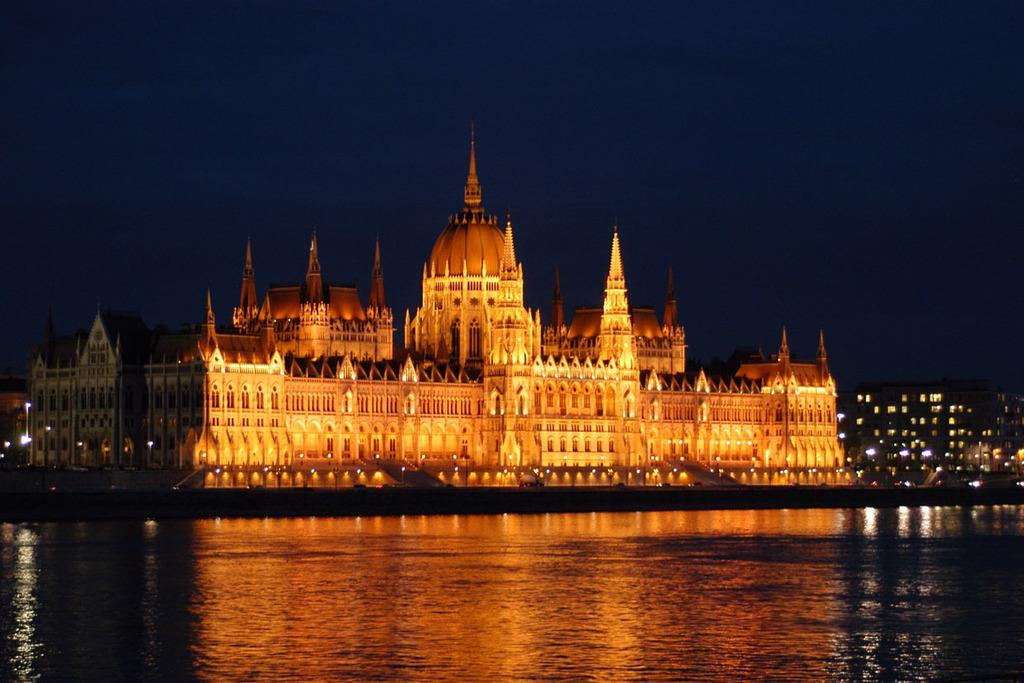What type of structures are present in the image? There are buildings in the image. What colors are the buildings painted in? The buildings are in yellow and orange colors. What else can be seen in the image besides the buildings? There are lights and water visible in the image. Who is the manager of the mountain in the image? There is no mountain present in the image, and therefore no manager associated with it. 